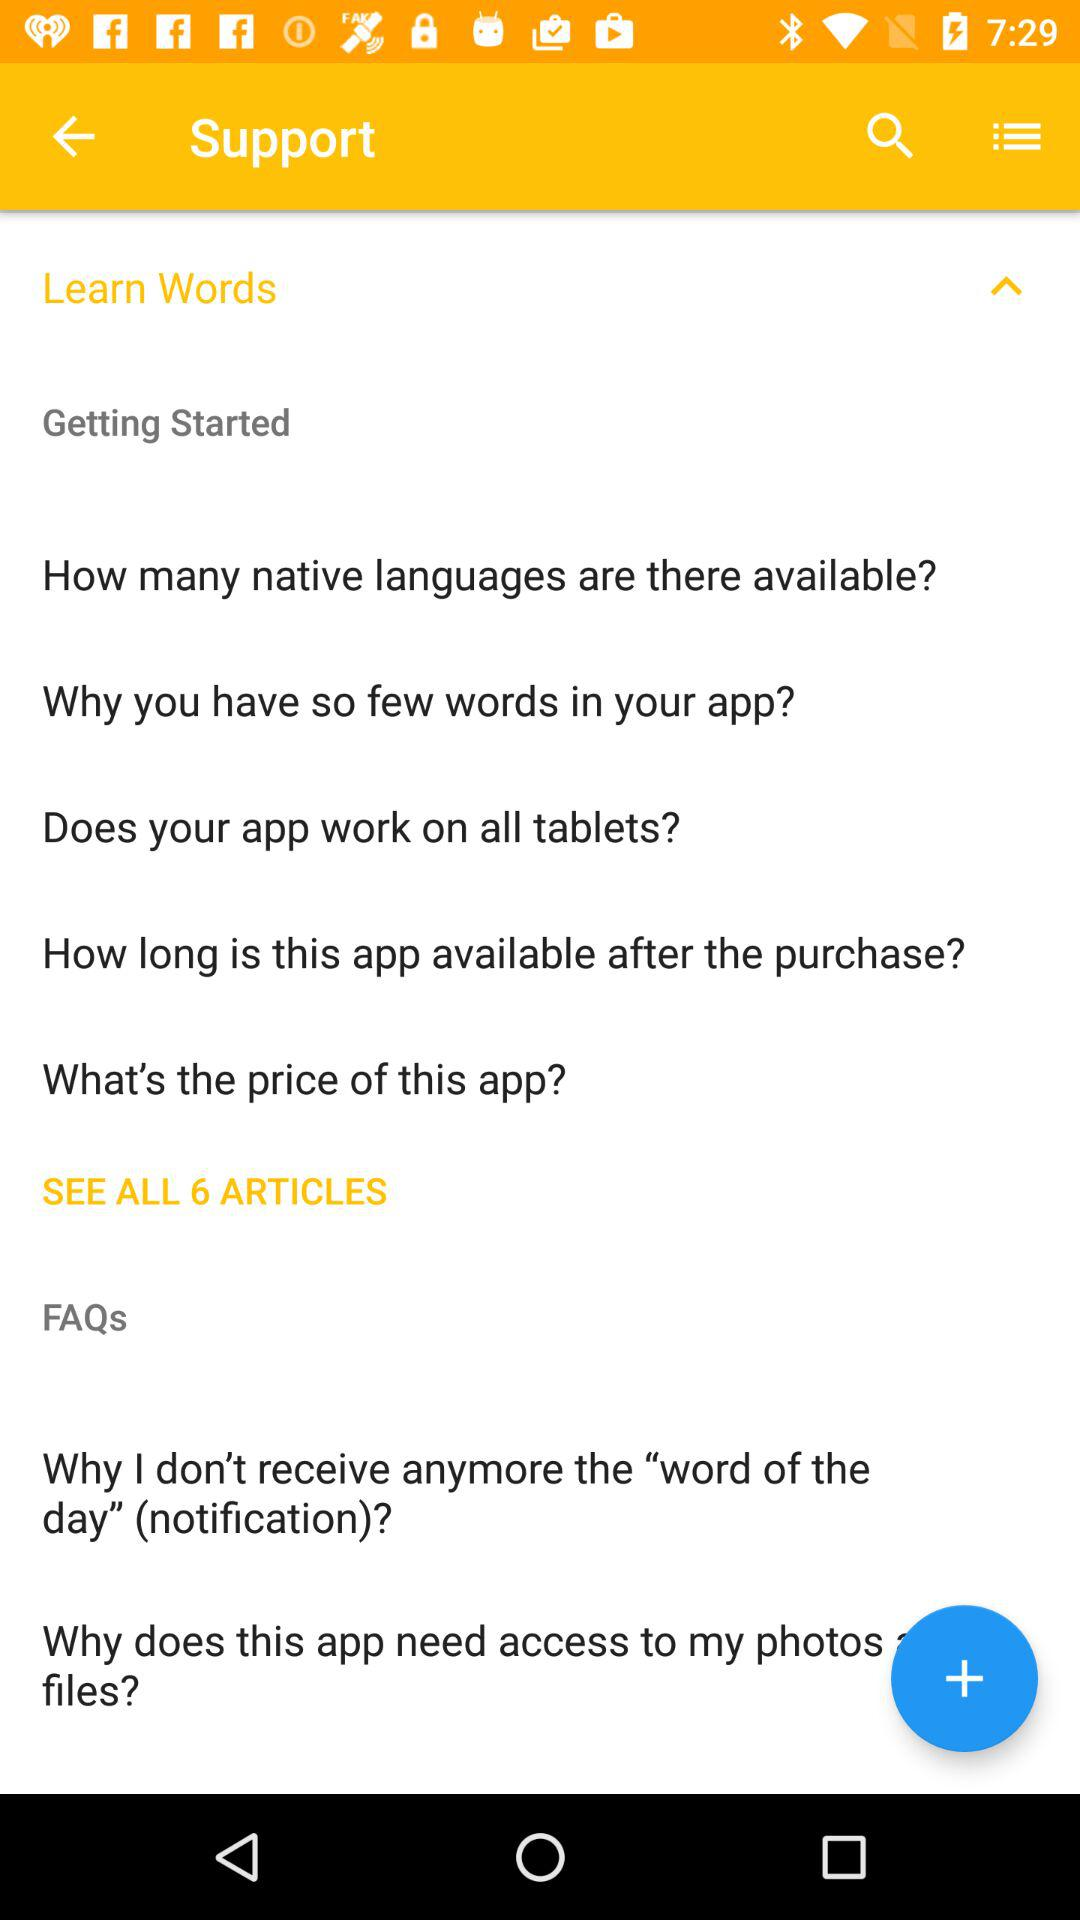How many articles are available in the support section?
Answer the question using a single word or phrase. 6 